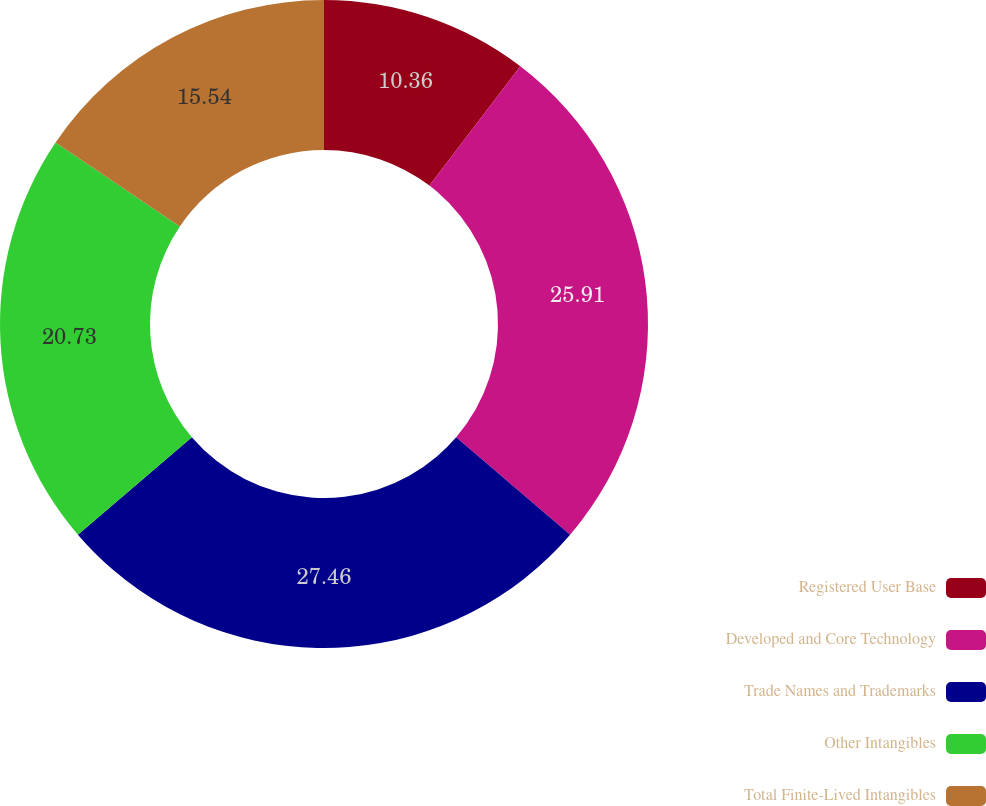<chart> <loc_0><loc_0><loc_500><loc_500><pie_chart><fcel>Registered User Base<fcel>Developed and Core Technology<fcel>Trade Names and Trademarks<fcel>Other Intangibles<fcel>Total Finite-Lived Intangibles<nl><fcel>10.36%<fcel>25.91%<fcel>27.46%<fcel>20.73%<fcel>15.54%<nl></chart> 